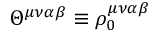Convert formula to latex. <formula><loc_0><loc_0><loc_500><loc_500>\Theta ^ { \mu \nu \alpha \beta } \equiv \rho _ { 0 } ^ { \mu \nu \alpha \beta }</formula> 